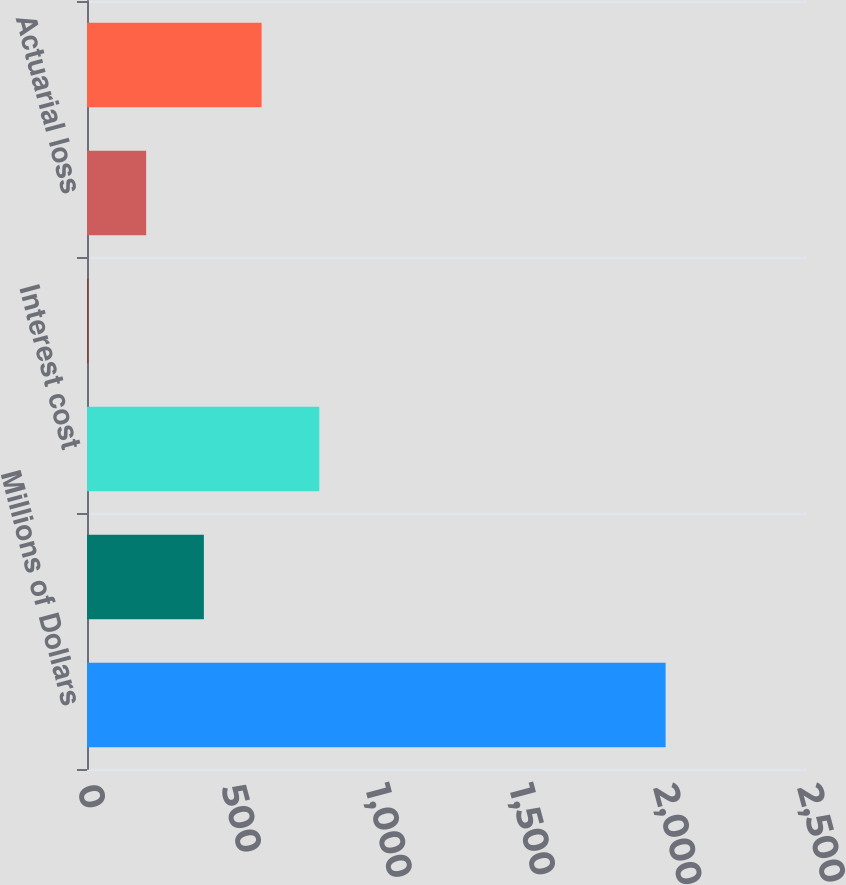<chart> <loc_0><loc_0><loc_500><loc_500><bar_chart><fcel>Millions of Dollars<fcel>Service cost<fcel>Interest cost<fcel>Prior service cost/(credit)<fcel>Actuarial loss<fcel>Net periodic benefit<nl><fcel>2009<fcel>405.8<fcel>806.6<fcel>5<fcel>205.4<fcel>606.2<nl></chart> 